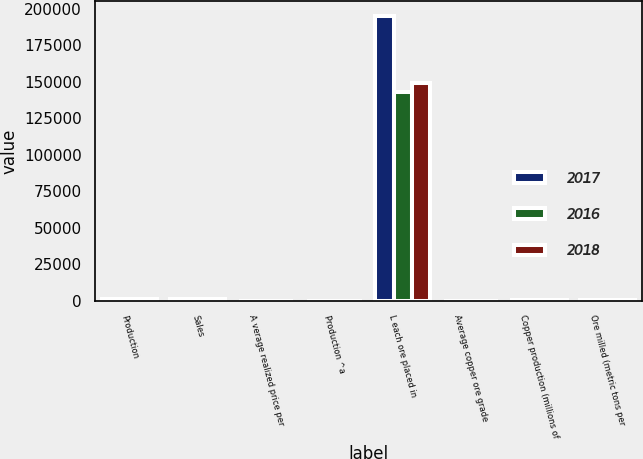<chart> <loc_0><loc_0><loc_500><loc_500><stacked_bar_chart><ecel><fcel>Production<fcel>Sales<fcel>A verage realized price per<fcel>Production ^a<fcel>L each ore placed in<fcel>Average copper ore grade<fcel>Copper production (millions of<fcel>Ore milled (metric tons per<nl><fcel>2017<fcel>1249<fcel>1253<fcel>2.87<fcel>28<fcel>195200<fcel>0.33<fcel>287<fcel>287<nl><fcel>2016<fcel>1235<fcel>1235<fcel>2.97<fcel>27<fcel>142800<fcel>0.37<fcel>255<fcel>287<nl><fcel>2018<fcel>1328<fcel>1332<fcel>2.31<fcel>21<fcel>149100<fcel>0.41<fcel>328<fcel>287<nl></chart> 